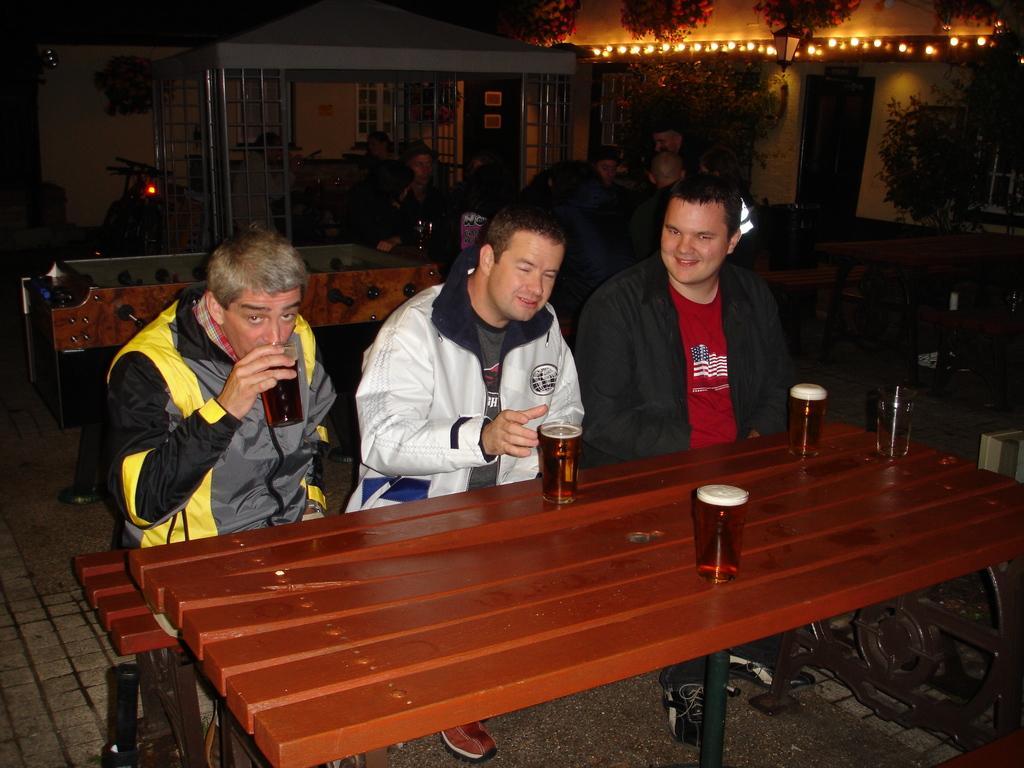Could you give a brief overview of what you see in this image? In this picture there are men those who are sitting in the center of the image in front of a table and there are glasses on the table and there are plants, lights, people and a house in the background area of the image, it seems to be there is a bicycle and a grill in the background area of the image. 